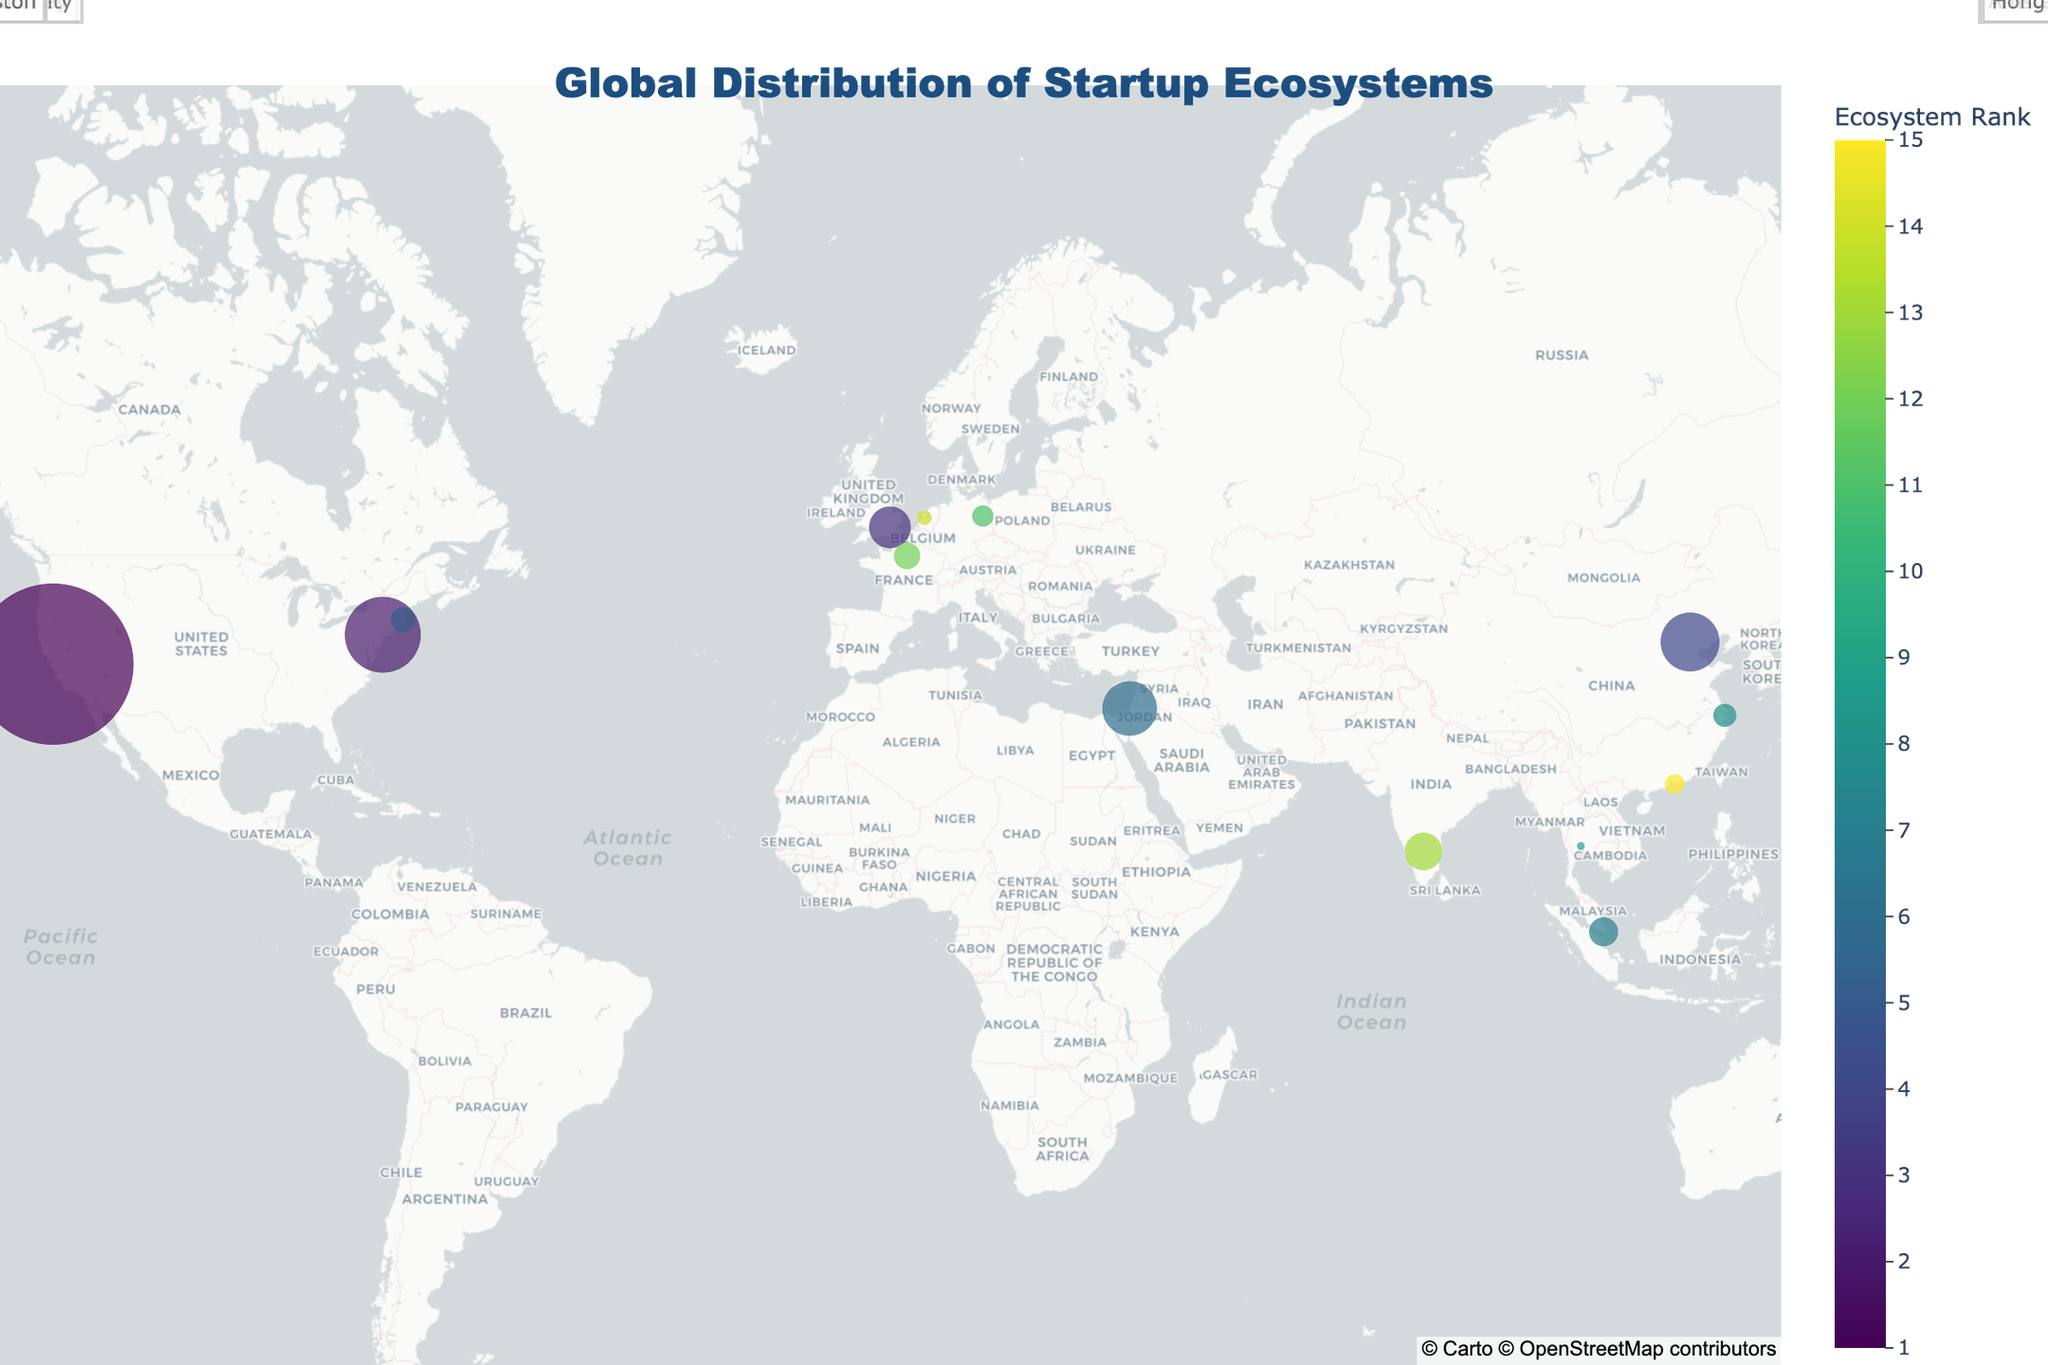What is the title of the map? The title is displayed at the top of the figure, stating the main subject of the map.
Answer: Global Distribution of Startup Ecosystems How many cities are marked on the map? Count the number of distinct city markers visible on the map.
Answer: 15 Which city has the highest number of startups? The city with the largest marker, representing the highest number of startups, would be this city.
Answer: Silicon Valley What is the ecosystem rank of Tokyo? Look for Tokyo in the figure and refer to the color scale, or the text label, to find its ecosystem rank.
Answer: 10 Which city has the smallest startup count in the top 15? By observing the smallest markers in the map and confirming startup count through hover text, we find this city.
Answer: Bangkok What is the difference in the startup count between Silicon Valley and New York City? Silicon Valley has 19000 startups and New York City has 9000 startups. The difference is calculated by subtracting these numbers.
Answer: 10000 Which two cities are closest to each other geographically? Look at the map for cities that are closest in proximity on the geographical layout.
Answer: Berlin and Amsterdam How does the startup count in Berlin compare to that in Paris? Berlin has 2600 startups and Paris has 3200 startups. The difference in startups is calculated by subtracting Berlin's count from Paris's count.
Answer: Paris has 600 more startups than Berlin What is the average number of startups in the cities ranked within the top five ecosystems? Sum the startup counts of the top five cities and divide by the number of these cities.
Answer: 8600 Which Asian city has the highest ecosystem rank? Among the Asian cities labeled on the map, look for the one with the lowest rank value displayed.
Answer: Beijing 